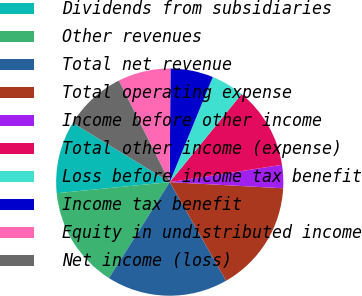Convert chart to OTSL. <chart><loc_0><loc_0><loc_500><loc_500><pie_chart><fcel>Dividends from subsidiaries<fcel>Other revenues<fcel>Total net revenue<fcel>Total operating expense<fcel>Income before other income<fcel>Total other income (expense)<fcel>Loss before income tax benefit<fcel>Income tax benefit<fcel>Equity in undistributed income<fcel>Net income (loss)<nl><fcel>10.28%<fcel>14.46%<fcel>17.25%<fcel>15.86%<fcel>3.3%<fcel>11.67%<fcel>4.7%<fcel>6.09%<fcel>7.49%<fcel>8.88%<nl></chart> 